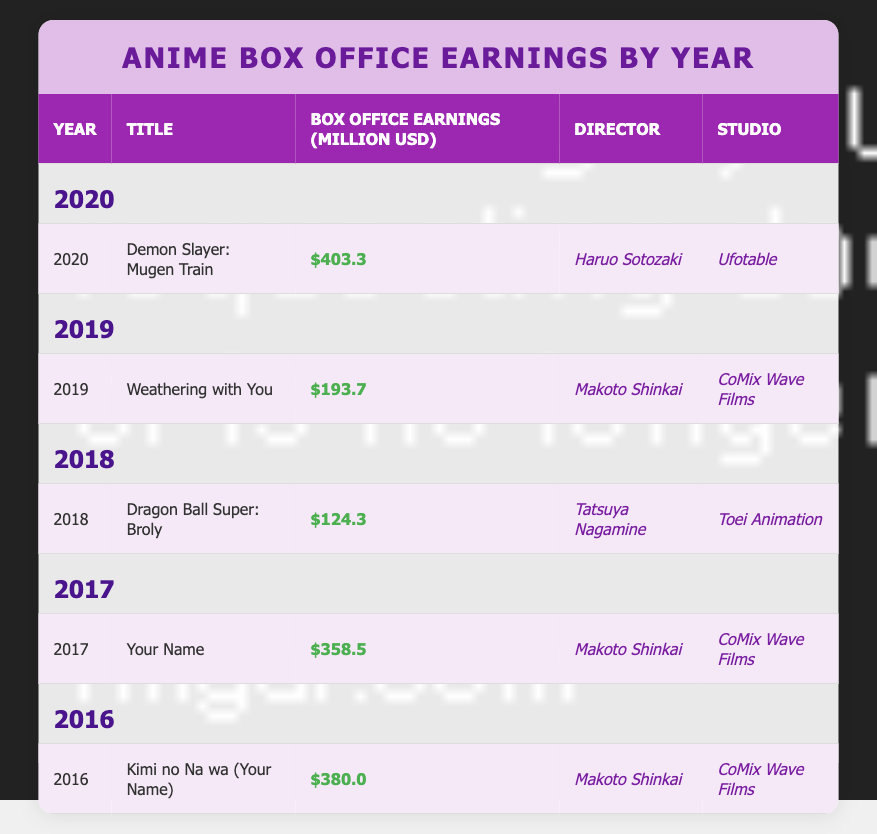What is the highest box office earning among the listed anime films? The table shows the box office earnings for each film. By comparing the earnings figures, "Demon Slayer: Mugen Train" has the highest earnings at 403.3 million USD.
Answer: 403.3 million USD Which anime film earned the least at the box office? By inspecting the earnings in the table, "Dragon Ball Super: Broly" has the lowest earnings of 124.3 million USD compared to the other films listed.
Answer: 124.3 million USD How many years are represented in the table? The table lists films from 2016 to 2020, which means there are 5 distinct years included in the data.
Answer: 5 years What is the average box office earning of all the listed films? To calculate the average, first, sum the box office earnings: 403.3 + 193.7 + 124.3 + 358.5 + 380.0 = 1459.8 million USD. Then divide by the number of films, which is 5: 1459.8 / 5 = 291.96 million USD.
Answer: 291.96 million USD Did any anime film directed by Makoto Shinkai earn over 300 million USD? The table shows that both "Your Name" and "Kimi no Na wa" were directed by Makoto Shinkai with earnings of 358.5 million USD and 380.0 million USD respectively, both exceeding 300 million USD.
Answer: Yes Which studio is associated with the most anime films in the table? By counting the entries in the table, "CoMix Wave Films" is listed as the studio for three films (2019, 2017, 2016), more than any other studio.
Answer: CoMix Wave Films What is the difference in box office earnings between "Demon Slayer: Mugen Train" and "Weathering with You"? The box office earnings of "Demon Slayer: Mugen Train" are 403.3 million USD and for "Weathering with You" are 193.7 million USD. The difference is calculated as 403.3 - 193.7 = 209.6 million USD.
Answer: 209.6 million USD Was "Kimi no Na wa" one of the top three highest-grossing films? Looking at the earnings, "Kimi no Na wa" earned 380.0 million USD. The top three films are "Demon Slayer: Mugen Train" (403.3 million USD), "Kimi no Na wa" (380.0 million USD), and "Your Name" (358.5 million USD); thus, it is in the top three.
Answer: Yes 